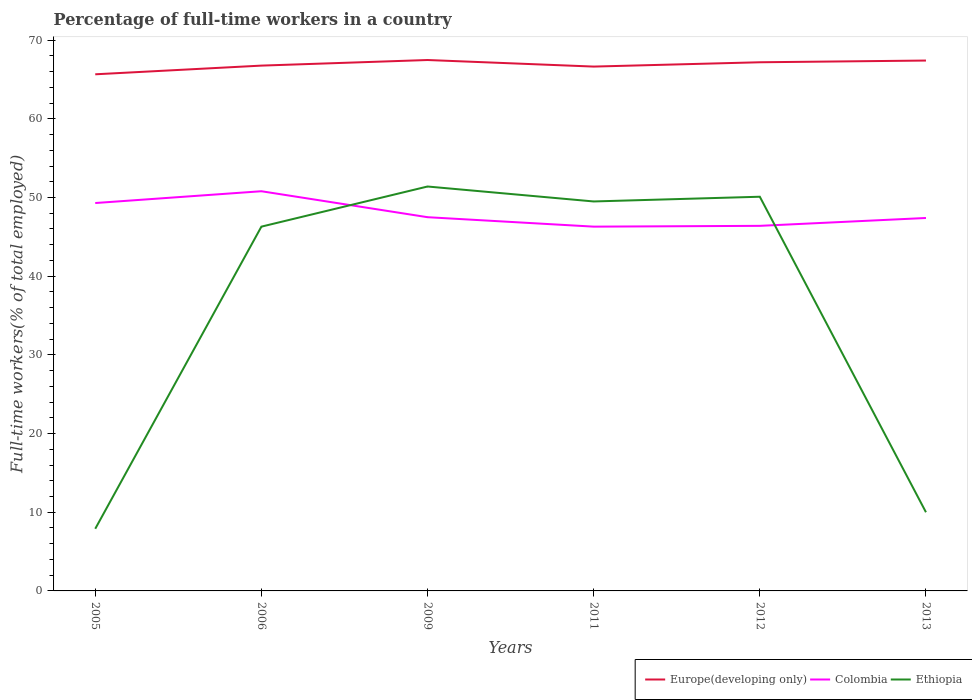Does the line corresponding to Colombia intersect with the line corresponding to Europe(developing only)?
Provide a succinct answer. No. Across all years, what is the maximum percentage of full-time workers in Ethiopia?
Offer a terse response. 7.9. In which year was the percentage of full-time workers in Europe(developing only) maximum?
Offer a terse response. 2005. What is the difference between the highest and the lowest percentage of full-time workers in Europe(developing only)?
Make the answer very short. 3. Is the percentage of full-time workers in Colombia strictly greater than the percentage of full-time workers in Ethiopia over the years?
Make the answer very short. No. Are the values on the major ticks of Y-axis written in scientific E-notation?
Your answer should be very brief. No. How are the legend labels stacked?
Your response must be concise. Horizontal. What is the title of the graph?
Offer a terse response. Percentage of full-time workers in a country. What is the label or title of the X-axis?
Your answer should be compact. Years. What is the label or title of the Y-axis?
Provide a short and direct response. Full-time workers(% of total employed). What is the Full-time workers(% of total employed) in Europe(developing only) in 2005?
Your answer should be very brief. 65.66. What is the Full-time workers(% of total employed) in Colombia in 2005?
Your response must be concise. 49.3. What is the Full-time workers(% of total employed) in Ethiopia in 2005?
Provide a short and direct response. 7.9. What is the Full-time workers(% of total employed) in Europe(developing only) in 2006?
Keep it short and to the point. 66.77. What is the Full-time workers(% of total employed) in Colombia in 2006?
Your answer should be very brief. 50.8. What is the Full-time workers(% of total employed) of Ethiopia in 2006?
Keep it short and to the point. 46.3. What is the Full-time workers(% of total employed) in Europe(developing only) in 2009?
Ensure brevity in your answer.  67.48. What is the Full-time workers(% of total employed) in Colombia in 2009?
Provide a short and direct response. 47.5. What is the Full-time workers(% of total employed) of Ethiopia in 2009?
Ensure brevity in your answer.  51.4. What is the Full-time workers(% of total employed) of Europe(developing only) in 2011?
Give a very brief answer. 66.64. What is the Full-time workers(% of total employed) in Colombia in 2011?
Provide a short and direct response. 46.3. What is the Full-time workers(% of total employed) of Ethiopia in 2011?
Your response must be concise. 49.5. What is the Full-time workers(% of total employed) of Europe(developing only) in 2012?
Provide a succinct answer. 67.19. What is the Full-time workers(% of total employed) in Colombia in 2012?
Your answer should be compact. 46.4. What is the Full-time workers(% of total employed) in Ethiopia in 2012?
Your answer should be compact. 50.1. What is the Full-time workers(% of total employed) in Europe(developing only) in 2013?
Ensure brevity in your answer.  67.41. What is the Full-time workers(% of total employed) of Colombia in 2013?
Ensure brevity in your answer.  47.4. What is the Full-time workers(% of total employed) in Ethiopia in 2013?
Ensure brevity in your answer.  10. Across all years, what is the maximum Full-time workers(% of total employed) in Europe(developing only)?
Keep it short and to the point. 67.48. Across all years, what is the maximum Full-time workers(% of total employed) of Colombia?
Your response must be concise. 50.8. Across all years, what is the maximum Full-time workers(% of total employed) in Ethiopia?
Offer a terse response. 51.4. Across all years, what is the minimum Full-time workers(% of total employed) in Europe(developing only)?
Offer a terse response. 65.66. Across all years, what is the minimum Full-time workers(% of total employed) in Colombia?
Ensure brevity in your answer.  46.3. Across all years, what is the minimum Full-time workers(% of total employed) of Ethiopia?
Your answer should be very brief. 7.9. What is the total Full-time workers(% of total employed) of Europe(developing only) in the graph?
Provide a succinct answer. 401.15. What is the total Full-time workers(% of total employed) in Colombia in the graph?
Provide a succinct answer. 287.7. What is the total Full-time workers(% of total employed) of Ethiopia in the graph?
Keep it short and to the point. 215.2. What is the difference between the Full-time workers(% of total employed) in Europe(developing only) in 2005 and that in 2006?
Give a very brief answer. -1.1. What is the difference between the Full-time workers(% of total employed) in Ethiopia in 2005 and that in 2006?
Keep it short and to the point. -38.4. What is the difference between the Full-time workers(% of total employed) of Europe(developing only) in 2005 and that in 2009?
Ensure brevity in your answer.  -1.82. What is the difference between the Full-time workers(% of total employed) in Ethiopia in 2005 and that in 2009?
Provide a short and direct response. -43.5. What is the difference between the Full-time workers(% of total employed) of Europe(developing only) in 2005 and that in 2011?
Ensure brevity in your answer.  -0.98. What is the difference between the Full-time workers(% of total employed) in Ethiopia in 2005 and that in 2011?
Provide a short and direct response. -41.6. What is the difference between the Full-time workers(% of total employed) in Europe(developing only) in 2005 and that in 2012?
Ensure brevity in your answer.  -1.53. What is the difference between the Full-time workers(% of total employed) in Ethiopia in 2005 and that in 2012?
Give a very brief answer. -42.2. What is the difference between the Full-time workers(% of total employed) of Europe(developing only) in 2005 and that in 2013?
Keep it short and to the point. -1.75. What is the difference between the Full-time workers(% of total employed) in Colombia in 2005 and that in 2013?
Provide a short and direct response. 1.9. What is the difference between the Full-time workers(% of total employed) of Ethiopia in 2005 and that in 2013?
Provide a succinct answer. -2.1. What is the difference between the Full-time workers(% of total employed) of Europe(developing only) in 2006 and that in 2009?
Your answer should be compact. -0.71. What is the difference between the Full-time workers(% of total employed) of Ethiopia in 2006 and that in 2009?
Offer a very short reply. -5.1. What is the difference between the Full-time workers(% of total employed) in Europe(developing only) in 2006 and that in 2011?
Offer a very short reply. 0.12. What is the difference between the Full-time workers(% of total employed) in Colombia in 2006 and that in 2011?
Offer a very short reply. 4.5. What is the difference between the Full-time workers(% of total employed) of Ethiopia in 2006 and that in 2011?
Offer a very short reply. -3.2. What is the difference between the Full-time workers(% of total employed) in Europe(developing only) in 2006 and that in 2012?
Offer a very short reply. -0.42. What is the difference between the Full-time workers(% of total employed) in Colombia in 2006 and that in 2012?
Give a very brief answer. 4.4. What is the difference between the Full-time workers(% of total employed) of Europe(developing only) in 2006 and that in 2013?
Your response must be concise. -0.64. What is the difference between the Full-time workers(% of total employed) in Ethiopia in 2006 and that in 2013?
Keep it short and to the point. 36.3. What is the difference between the Full-time workers(% of total employed) in Europe(developing only) in 2009 and that in 2011?
Give a very brief answer. 0.83. What is the difference between the Full-time workers(% of total employed) of Ethiopia in 2009 and that in 2011?
Offer a terse response. 1.9. What is the difference between the Full-time workers(% of total employed) in Europe(developing only) in 2009 and that in 2012?
Your response must be concise. 0.29. What is the difference between the Full-time workers(% of total employed) in Colombia in 2009 and that in 2012?
Keep it short and to the point. 1.1. What is the difference between the Full-time workers(% of total employed) of Europe(developing only) in 2009 and that in 2013?
Give a very brief answer. 0.07. What is the difference between the Full-time workers(% of total employed) of Colombia in 2009 and that in 2013?
Keep it short and to the point. 0.1. What is the difference between the Full-time workers(% of total employed) of Ethiopia in 2009 and that in 2013?
Make the answer very short. 41.4. What is the difference between the Full-time workers(% of total employed) in Europe(developing only) in 2011 and that in 2012?
Offer a very short reply. -0.55. What is the difference between the Full-time workers(% of total employed) in Ethiopia in 2011 and that in 2012?
Ensure brevity in your answer.  -0.6. What is the difference between the Full-time workers(% of total employed) of Europe(developing only) in 2011 and that in 2013?
Ensure brevity in your answer.  -0.77. What is the difference between the Full-time workers(% of total employed) of Colombia in 2011 and that in 2013?
Make the answer very short. -1.1. What is the difference between the Full-time workers(% of total employed) of Ethiopia in 2011 and that in 2013?
Make the answer very short. 39.5. What is the difference between the Full-time workers(% of total employed) in Europe(developing only) in 2012 and that in 2013?
Your answer should be compact. -0.22. What is the difference between the Full-time workers(% of total employed) in Ethiopia in 2012 and that in 2013?
Your answer should be compact. 40.1. What is the difference between the Full-time workers(% of total employed) in Europe(developing only) in 2005 and the Full-time workers(% of total employed) in Colombia in 2006?
Provide a succinct answer. 14.86. What is the difference between the Full-time workers(% of total employed) of Europe(developing only) in 2005 and the Full-time workers(% of total employed) of Ethiopia in 2006?
Your answer should be very brief. 19.36. What is the difference between the Full-time workers(% of total employed) of Colombia in 2005 and the Full-time workers(% of total employed) of Ethiopia in 2006?
Make the answer very short. 3. What is the difference between the Full-time workers(% of total employed) of Europe(developing only) in 2005 and the Full-time workers(% of total employed) of Colombia in 2009?
Ensure brevity in your answer.  18.16. What is the difference between the Full-time workers(% of total employed) of Europe(developing only) in 2005 and the Full-time workers(% of total employed) of Ethiopia in 2009?
Offer a very short reply. 14.26. What is the difference between the Full-time workers(% of total employed) of Colombia in 2005 and the Full-time workers(% of total employed) of Ethiopia in 2009?
Your response must be concise. -2.1. What is the difference between the Full-time workers(% of total employed) of Europe(developing only) in 2005 and the Full-time workers(% of total employed) of Colombia in 2011?
Offer a terse response. 19.36. What is the difference between the Full-time workers(% of total employed) in Europe(developing only) in 2005 and the Full-time workers(% of total employed) in Ethiopia in 2011?
Offer a terse response. 16.16. What is the difference between the Full-time workers(% of total employed) of Europe(developing only) in 2005 and the Full-time workers(% of total employed) of Colombia in 2012?
Your answer should be compact. 19.26. What is the difference between the Full-time workers(% of total employed) in Europe(developing only) in 2005 and the Full-time workers(% of total employed) in Ethiopia in 2012?
Give a very brief answer. 15.56. What is the difference between the Full-time workers(% of total employed) of Colombia in 2005 and the Full-time workers(% of total employed) of Ethiopia in 2012?
Give a very brief answer. -0.8. What is the difference between the Full-time workers(% of total employed) of Europe(developing only) in 2005 and the Full-time workers(% of total employed) of Colombia in 2013?
Ensure brevity in your answer.  18.26. What is the difference between the Full-time workers(% of total employed) of Europe(developing only) in 2005 and the Full-time workers(% of total employed) of Ethiopia in 2013?
Offer a very short reply. 55.66. What is the difference between the Full-time workers(% of total employed) of Colombia in 2005 and the Full-time workers(% of total employed) of Ethiopia in 2013?
Offer a terse response. 39.3. What is the difference between the Full-time workers(% of total employed) in Europe(developing only) in 2006 and the Full-time workers(% of total employed) in Colombia in 2009?
Keep it short and to the point. 19.27. What is the difference between the Full-time workers(% of total employed) in Europe(developing only) in 2006 and the Full-time workers(% of total employed) in Ethiopia in 2009?
Ensure brevity in your answer.  15.37. What is the difference between the Full-time workers(% of total employed) in Europe(developing only) in 2006 and the Full-time workers(% of total employed) in Colombia in 2011?
Keep it short and to the point. 20.47. What is the difference between the Full-time workers(% of total employed) of Europe(developing only) in 2006 and the Full-time workers(% of total employed) of Ethiopia in 2011?
Your answer should be compact. 17.27. What is the difference between the Full-time workers(% of total employed) in Colombia in 2006 and the Full-time workers(% of total employed) in Ethiopia in 2011?
Provide a succinct answer. 1.3. What is the difference between the Full-time workers(% of total employed) in Europe(developing only) in 2006 and the Full-time workers(% of total employed) in Colombia in 2012?
Your answer should be very brief. 20.37. What is the difference between the Full-time workers(% of total employed) in Europe(developing only) in 2006 and the Full-time workers(% of total employed) in Ethiopia in 2012?
Ensure brevity in your answer.  16.67. What is the difference between the Full-time workers(% of total employed) of Colombia in 2006 and the Full-time workers(% of total employed) of Ethiopia in 2012?
Ensure brevity in your answer.  0.7. What is the difference between the Full-time workers(% of total employed) of Europe(developing only) in 2006 and the Full-time workers(% of total employed) of Colombia in 2013?
Provide a short and direct response. 19.37. What is the difference between the Full-time workers(% of total employed) in Europe(developing only) in 2006 and the Full-time workers(% of total employed) in Ethiopia in 2013?
Your response must be concise. 56.77. What is the difference between the Full-time workers(% of total employed) of Colombia in 2006 and the Full-time workers(% of total employed) of Ethiopia in 2013?
Give a very brief answer. 40.8. What is the difference between the Full-time workers(% of total employed) in Europe(developing only) in 2009 and the Full-time workers(% of total employed) in Colombia in 2011?
Provide a short and direct response. 21.18. What is the difference between the Full-time workers(% of total employed) in Europe(developing only) in 2009 and the Full-time workers(% of total employed) in Ethiopia in 2011?
Your answer should be very brief. 17.98. What is the difference between the Full-time workers(% of total employed) in Europe(developing only) in 2009 and the Full-time workers(% of total employed) in Colombia in 2012?
Offer a very short reply. 21.08. What is the difference between the Full-time workers(% of total employed) of Europe(developing only) in 2009 and the Full-time workers(% of total employed) of Ethiopia in 2012?
Provide a succinct answer. 17.38. What is the difference between the Full-time workers(% of total employed) of Colombia in 2009 and the Full-time workers(% of total employed) of Ethiopia in 2012?
Offer a very short reply. -2.6. What is the difference between the Full-time workers(% of total employed) in Europe(developing only) in 2009 and the Full-time workers(% of total employed) in Colombia in 2013?
Offer a terse response. 20.08. What is the difference between the Full-time workers(% of total employed) in Europe(developing only) in 2009 and the Full-time workers(% of total employed) in Ethiopia in 2013?
Offer a very short reply. 57.48. What is the difference between the Full-time workers(% of total employed) of Colombia in 2009 and the Full-time workers(% of total employed) of Ethiopia in 2013?
Your answer should be very brief. 37.5. What is the difference between the Full-time workers(% of total employed) in Europe(developing only) in 2011 and the Full-time workers(% of total employed) in Colombia in 2012?
Provide a succinct answer. 20.24. What is the difference between the Full-time workers(% of total employed) in Europe(developing only) in 2011 and the Full-time workers(% of total employed) in Ethiopia in 2012?
Your answer should be very brief. 16.54. What is the difference between the Full-time workers(% of total employed) in Colombia in 2011 and the Full-time workers(% of total employed) in Ethiopia in 2012?
Your answer should be compact. -3.8. What is the difference between the Full-time workers(% of total employed) of Europe(developing only) in 2011 and the Full-time workers(% of total employed) of Colombia in 2013?
Ensure brevity in your answer.  19.24. What is the difference between the Full-time workers(% of total employed) in Europe(developing only) in 2011 and the Full-time workers(% of total employed) in Ethiopia in 2013?
Provide a short and direct response. 56.64. What is the difference between the Full-time workers(% of total employed) in Colombia in 2011 and the Full-time workers(% of total employed) in Ethiopia in 2013?
Your answer should be compact. 36.3. What is the difference between the Full-time workers(% of total employed) of Europe(developing only) in 2012 and the Full-time workers(% of total employed) of Colombia in 2013?
Your answer should be very brief. 19.79. What is the difference between the Full-time workers(% of total employed) in Europe(developing only) in 2012 and the Full-time workers(% of total employed) in Ethiopia in 2013?
Make the answer very short. 57.19. What is the difference between the Full-time workers(% of total employed) of Colombia in 2012 and the Full-time workers(% of total employed) of Ethiopia in 2013?
Offer a very short reply. 36.4. What is the average Full-time workers(% of total employed) of Europe(developing only) per year?
Provide a succinct answer. 66.86. What is the average Full-time workers(% of total employed) in Colombia per year?
Offer a terse response. 47.95. What is the average Full-time workers(% of total employed) of Ethiopia per year?
Offer a very short reply. 35.87. In the year 2005, what is the difference between the Full-time workers(% of total employed) in Europe(developing only) and Full-time workers(% of total employed) in Colombia?
Your answer should be compact. 16.36. In the year 2005, what is the difference between the Full-time workers(% of total employed) of Europe(developing only) and Full-time workers(% of total employed) of Ethiopia?
Make the answer very short. 57.76. In the year 2005, what is the difference between the Full-time workers(% of total employed) in Colombia and Full-time workers(% of total employed) in Ethiopia?
Ensure brevity in your answer.  41.4. In the year 2006, what is the difference between the Full-time workers(% of total employed) in Europe(developing only) and Full-time workers(% of total employed) in Colombia?
Keep it short and to the point. 15.97. In the year 2006, what is the difference between the Full-time workers(% of total employed) in Europe(developing only) and Full-time workers(% of total employed) in Ethiopia?
Ensure brevity in your answer.  20.47. In the year 2006, what is the difference between the Full-time workers(% of total employed) in Colombia and Full-time workers(% of total employed) in Ethiopia?
Make the answer very short. 4.5. In the year 2009, what is the difference between the Full-time workers(% of total employed) in Europe(developing only) and Full-time workers(% of total employed) in Colombia?
Provide a succinct answer. 19.98. In the year 2009, what is the difference between the Full-time workers(% of total employed) of Europe(developing only) and Full-time workers(% of total employed) of Ethiopia?
Make the answer very short. 16.08. In the year 2009, what is the difference between the Full-time workers(% of total employed) of Colombia and Full-time workers(% of total employed) of Ethiopia?
Provide a short and direct response. -3.9. In the year 2011, what is the difference between the Full-time workers(% of total employed) of Europe(developing only) and Full-time workers(% of total employed) of Colombia?
Provide a succinct answer. 20.34. In the year 2011, what is the difference between the Full-time workers(% of total employed) in Europe(developing only) and Full-time workers(% of total employed) in Ethiopia?
Ensure brevity in your answer.  17.14. In the year 2011, what is the difference between the Full-time workers(% of total employed) of Colombia and Full-time workers(% of total employed) of Ethiopia?
Make the answer very short. -3.2. In the year 2012, what is the difference between the Full-time workers(% of total employed) of Europe(developing only) and Full-time workers(% of total employed) of Colombia?
Offer a terse response. 20.79. In the year 2012, what is the difference between the Full-time workers(% of total employed) in Europe(developing only) and Full-time workers(% of total employed) in Ethiopia?
Make the answer very short. 17.09. In the year 2013, what is the difference between the Full-time workers(% of total employed) in Europe(developing only) and Full-time workers(% of total employed) in Colombia?
Offer a terse response. 20.01. In the year 2013, what is the difference between the Full-time workers(% of total employed) in Europe(developing only) and Full-time workers(% of total employed) in Ethiopia?
Give a very brief answer. 57.41. In the year 2013, what is the difference between the Full-time workers(% of total employed) of Colombia and Full-time workers(% of total employed) of Ethiopia?
Give a very brief answer. 37.4. What is the ratio of the Full-time workers(% of total employed) in Europe(developing only) in 2005 to that in 2006?
Make the answer very short. 0.98. What is the ratio of the Full-time workers(% of total employed) in Colombia in 2005 to that in 2006?
Provide a succinct answer. 0.97. What is the ratio of the Full-time workers(% of total employed) in Ethiopia in 2005 to that in 2006?
Provide a short and direct response. 0.17. What is the ratio of the Full-time workers(% of total employed) in Europe(developing only) in 2005 to that in 2009?
Your answer should be compact. 0.97. What is the ratio of the Full-time workers(% of total employed) in Colombia in 2005 to that in 2009?
Your answer should be compact. 1.04. What is the ratio of the Full-time workers(% of total employed) of Ethiopia in 2005 to that in 2009?
Provide a succinct answer. 0.15. What is the ratio of the Full-time workers(% of total employed) in Europe(developing only) in 2005 to that in 2011?
Offer a terse response. 0.99. What is the ratio of the Full-time workers(% of total employed) of Colombia in 2005 to that in 2011?
Provide a succinct answer. 1.06. What is the ratio of the Full-time workers(% of total employed) in Ethiopia in 2005 to that in 2011?
Provide a short and direct response. 0.16. What is the ratio of the Full-time workers(% of total employed) of Europe(developing only) in 2005 to that in 2012?
Give a very brief answer. 0.98. What is the ratio of the Full-time workers(% of total employed) of Colombia in 2005 to that in 2012?
Offer a terse response. 1.06. What is the ratio of the Full-time workers(% of total employed) in Ethiopia in 2005 to that in 2012?
Ensure brevity in your answer.  0.16. What is the ratio of the Full-time workers(% of total employed) in Europe(developing only) in 2005 to that in 2013?
Offer a very short reply. 0.97. What is the ratio of the Full-time workers(% of total employed) of Colombia in 2005 to that in 2013?
Offer a very short reply. 1.04. What is the ratio of the Full-time workers(% of total employed) in Ethiopia in 2005 to that in 2013?
Your answer should be very brief. 0.79. What is the ratio of the Full-time workers(% of total employed) in Europe(developing only) in 2006 to that in 2009?
Keep it short and to the point. 0.99. What is the ratio of the Full-time workers(% of total employed) of Colombia in 2006 to that in 2009?
Your answer should be very brief. 1.07. What is the ratio of the Full-time workers(% of total employed) in Ethiopia in 2006 to that in 2009?
Provide a succinct answer. 0.9. What is the ratio of the Full-time workers(% of total employed) of Colombia in 2006 to that in 2011?
Your answer should be compact. 1.1. What is the ratio of the Full-time workers(% of total employed) in Ethiopia in 2006 to that in 2011?
Give a very brief answer. 0.94. What is the ratio of the Full-time workers(% of total employed) in Colombia in 2006 to that in 2012?
Offer a terse response. 1.09. What is the ratio of the Full-time workers(% of total employed) in Ethiopia in 2006 to that in 2012?
Provide a short and direct response. 0.92. What is the ratio of the Full-time workers(% of total employed) of Colombia in 2006 to that in 2013?
Give a very brief answer. 1.07. What is the ratio of the Full-time workers(% of total employed) in Ethiopia in 2006 to that in 2013?
Your answer should be very brief. 4.63. What is the ratio of the Full-time workers(% of total employed) in Europe(developing only) in 2009 to that in 2011?
Make the answer very short. 1.01. What is the ratio of the Full-time workers(% of total employed) in Colombia in 2009 to that in 2011?
Your response must be concise. 1.03. What is the ratio of the Full-time workers(% of total employed) of Ethiopia in 2009 to that in 2011?
Offer a terse response. 1.04. What is the ratio of the Full-time workers(% of total employed) of Colombia in 2009 to that in 2012?
Your answer should be very brief. 1.02. What is the ratio of the Full-time workers(% of total employed) of Ethiopia in 2009 to that in 2012?
Your answer should be compact. 1.03. What is the ratio of the Full-time workers(% of total employed) in Europe(developing only) in 2009 to that in 2013?
Your answer should be compact. 1. What is the ratio of the Full-time workers(% of total employed) of Ethiopia in 2009 to that in 2013?
Provide a short and direct response. 5.14. What is the ratio of the Full-time workers(% of total employed) in Europe(developing only) in 2011 to that in 2013?
Keep it short and to the point. 0.99. What is the ratio of the Full-time workers(% of total employed) of Colombia in 2011 to that in 2013?
Offer a terse response. 0.98. What is the ratio of the Full-time workers(% of total employed) in Ethiopia in 2011 to that in 2013?
Your answer should be compact. 4.95. What is the ratio of the Full-time workers(% of total employed) of Colombia in 2012 to that in 2013?
Offer a very short reply. 0.98. What is the ratio of the Full-time workers(% of total employed) in Ethiopia in 2012 to that in 2013?
Provide a short and direct response. 5.01. What is the difference between the highest and the second highest Full-time workers(% of total employed) of Europe(developing only)?
Your answer should be compact. 0.07. What is the difference between the highest and the second highest Full-time workers(% of total employed) in Colombia?
Provide a short and direct response. 1.5. What is the difference between the highest and the second highest Full-time workers(% of total employed) in Ethiopia?
Ensure brevity in your answer.  1.3. What is the difference between the highest and the lowest Full-time workers(% of total employed) in Europe(developing only)?
Provide a succinct answer. 1.82. What is the difference between the highest and the lowest Full-time workers(% of total employed) of Colombia?
Offer a very short reply. 4.5. What is the difference between the highest and the lowest Full-time workers(% of total employed) in Ethiopia?
Offer a very short reply. 43.5. 